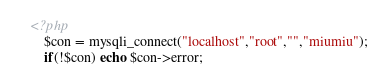Convert code to text. <code><loc_0><loc_0><loc_500><loc_500><_PHP_><?php
    $con = mysqli_connect("localhost","root","","miumiu");
    if(!$con) echo $con->error;</code> 